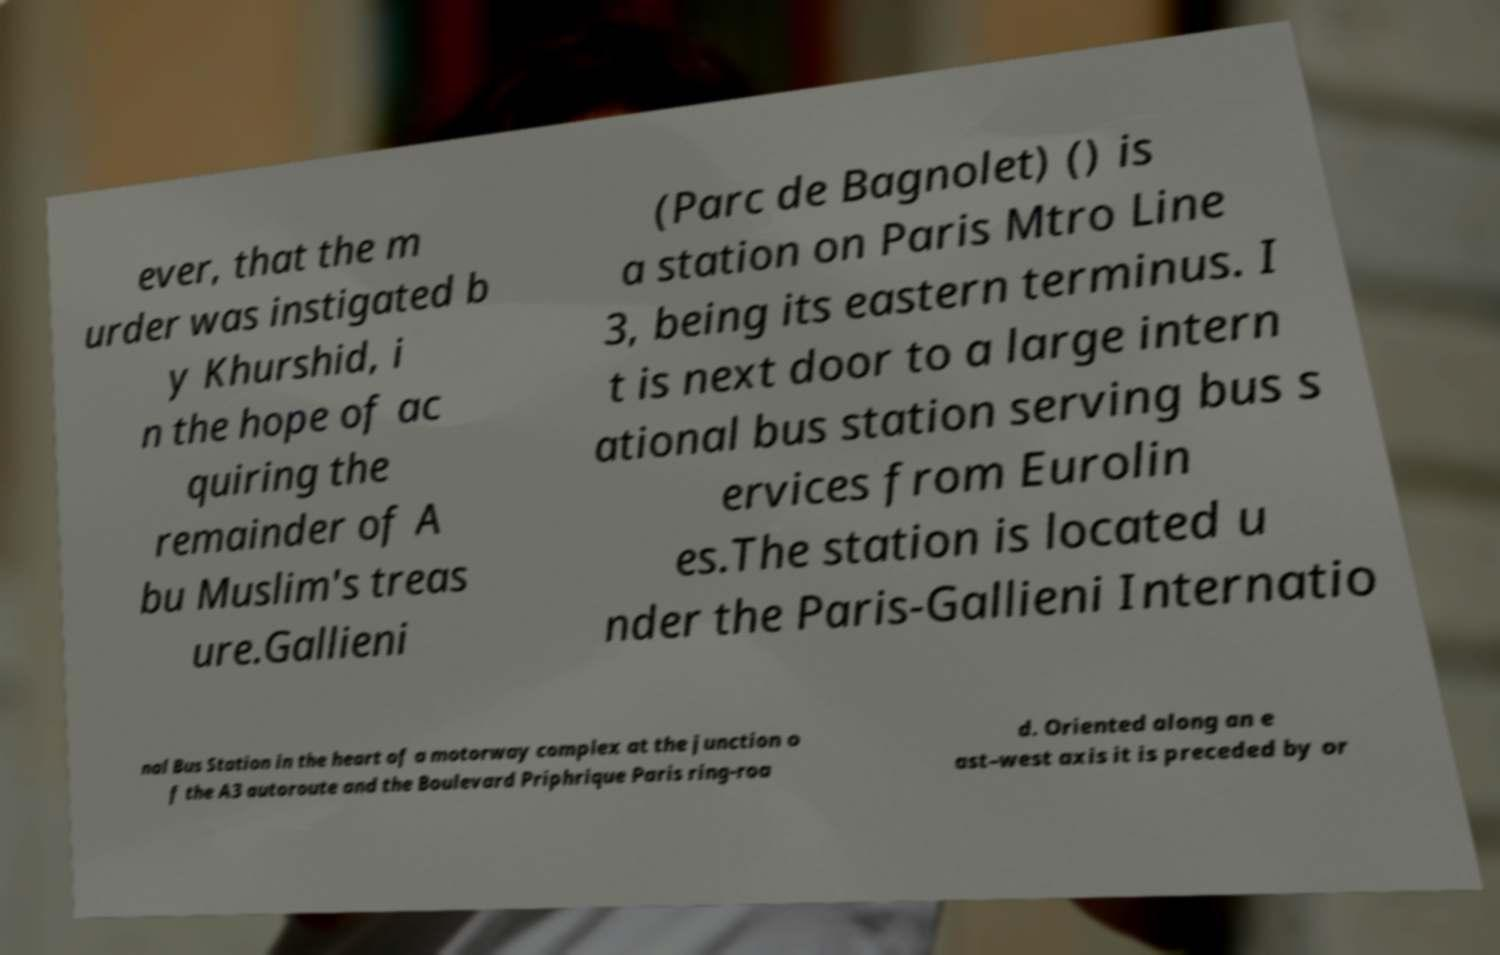There's text embedded in this image that I need extracted. Can you transcribe it verbatim? ever, that the m urder was instigated b y Khurshid, i n the hope of ac quiring the remainder of A bu Muslim's treas ure.Gallieni (Parc de Bagnolet) () is a station on Paris Mtro Line 3, being its eastern terminus. I t is next door to a large intern ational bus station serving bus s ervices from Eurolin es.The station is located u nder the Paris-Gallieni Internatio nal Bus Station in the heart of a motorway complex at the junction o f the A3 autoroute and the Boulevard Priphrique Paris ring-roa d. Oriented along an e ast–west axis it is preceded by or 